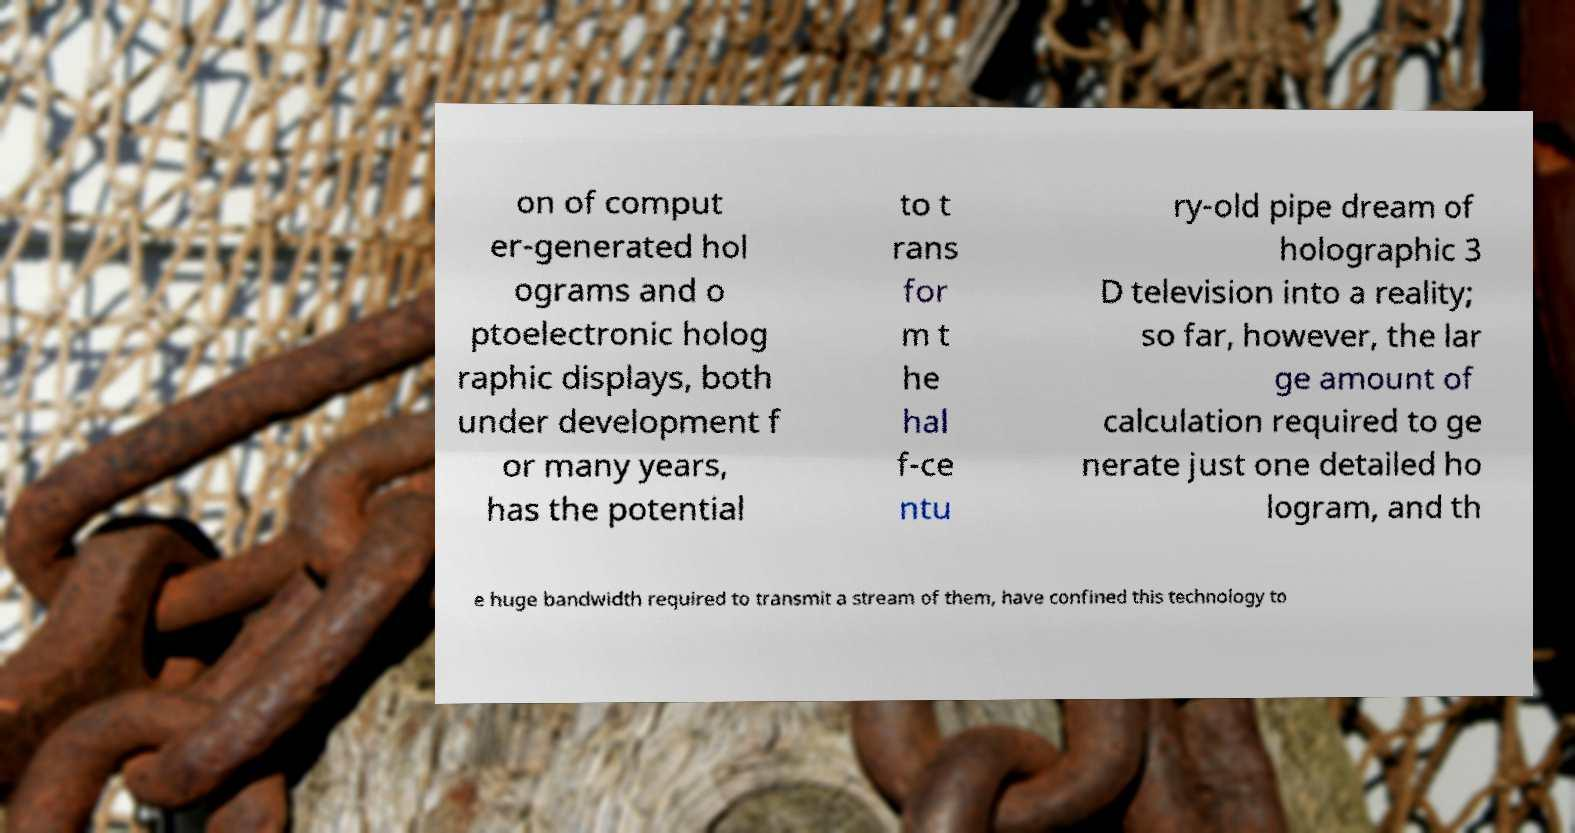I need the written content from this picture converted into text. Can you do that? on of comput er-generated hol ograms and o ptoelectronic holog raphic displays, both under development f or many years, has the potential to t rans for m t he hal f-ce ntu ry-old pipe dream of holographic 3 D television into a reality; so far, however, the lar ge amount of calculation required to ge nerate just one detailed ho logram, and th e huge bandwidth required to transmit a stream of them, have confined this technology to 